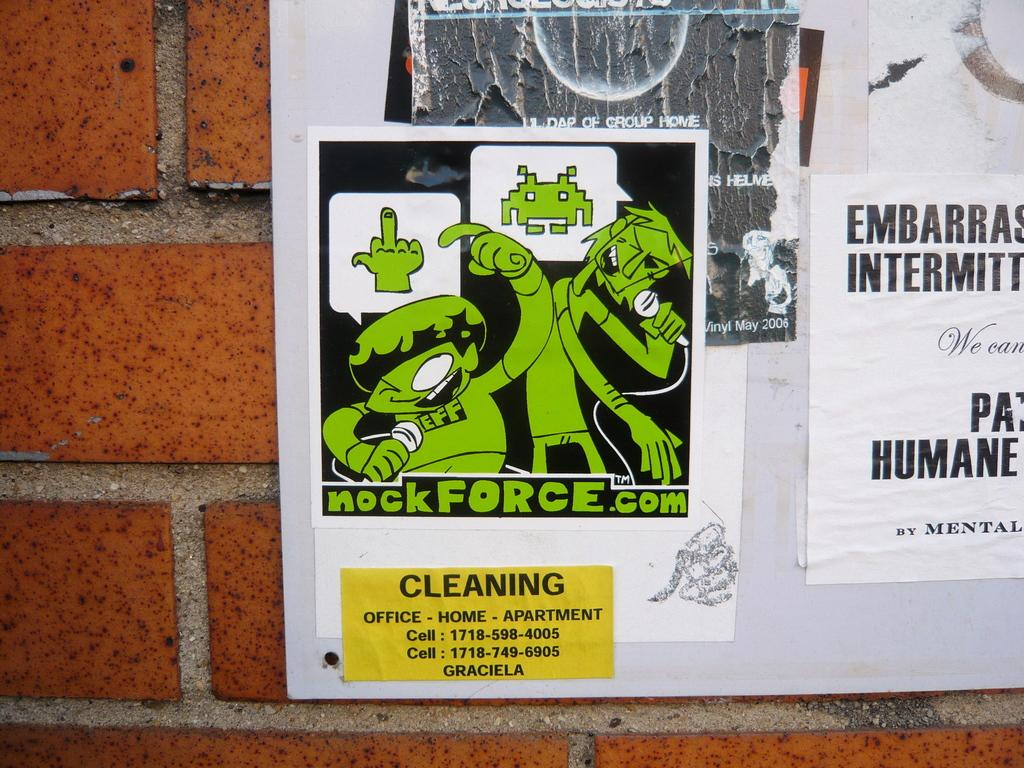What is attached to the wall in the image? There are posters on a notice board in the image. What color is the notice board? The notice board is white in color. How is the notice board secured to the wall? The notice board is fixed to the wall. What type of curve can be seen on the birthday calendar in the image? There is no birthday calendar present in the image. 